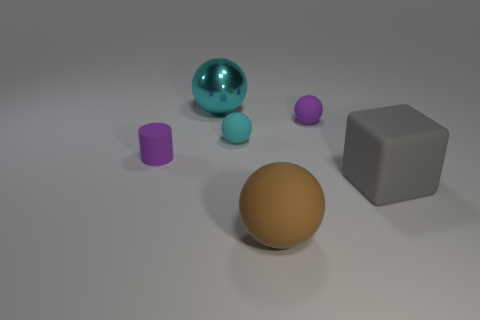Subtract all big cyan metal spheres. How many spheres are left? 3 Add 3 brown rubber objects. How many objects exist? 9 Subtract all brown balls. How many balls are left? 3 Subtract all cylinders. How many objects are left? 5 Add 2 small yellow matte cylinders. How many small yellow matte cylinders exist? 2 Subtract 0 green cylinders. How many objects are left? 6 Subtract 1 balls. How many balls are left? 3 Subtract all yellow cylinders. Subtract all purple cubes. How many cylinders are left? 1 Subtract all green spheres. How many cyan cubes are left? 0 Subtract all tiny matte things. Subtract all big blue rubber cylinders. How many objects are left? 3 